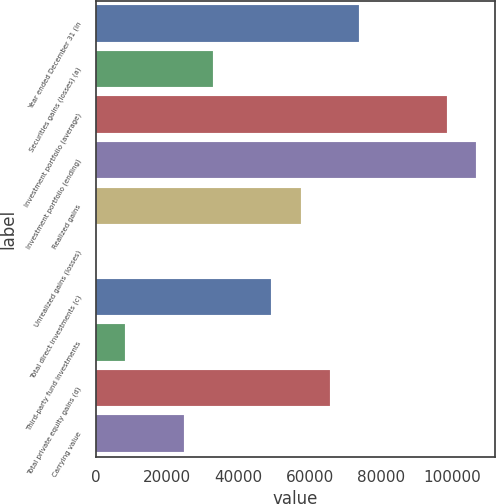Convert chart. <chart><loc_0><loc_0><loc_500><loc_500><bar_chart><fcel>Year ended December 31 (in<fcel>Securities gains (losses) (a)<fcel>Investment portfolio (average)<fcel>Investment portfolio (ending)<fcel>Realized gains<fcel>Unrealized gains (losses)<fcel>Total direct investments (c)<fcel>Third-party fund investments<fcel>Total private equity gains (d)<fcel>Carrying value<nl><fcel>73882<fcel>32837<fcel>98509<fcel>106718<fcel>57464<fcel>1<fcel>49255<fcel>8210<fcel>65673<fcel>24628<nl></chart> 